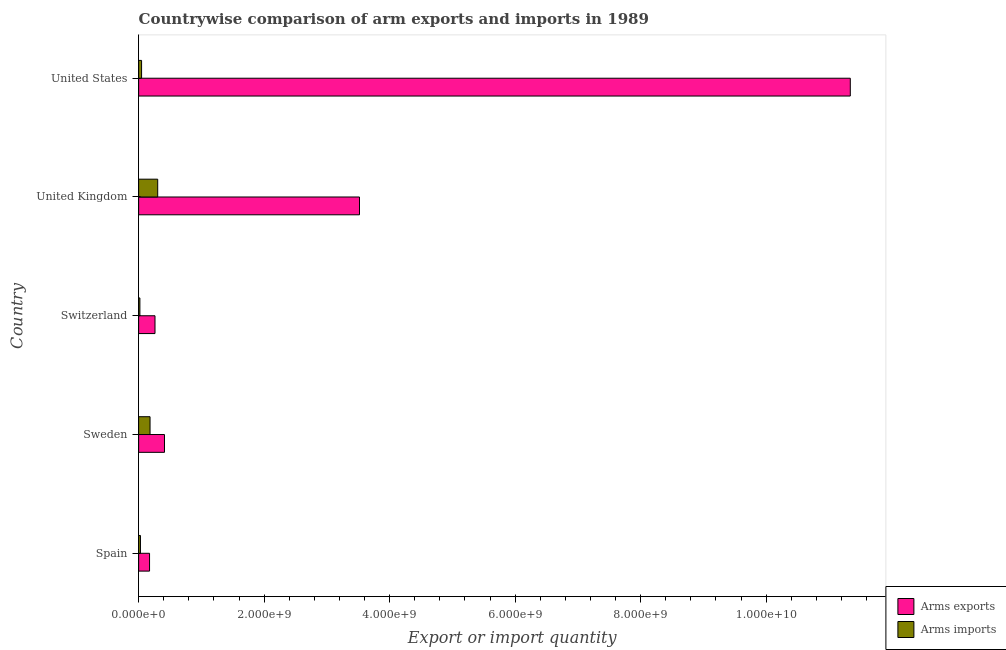How many groups of bars are there?
Offer a terse response. 5. Are the number of bars per tick equal to the number of legend labels?
Offer a terse response. Yes. How many bars are there on the 2nd tick from the top?
Provide a succinct answer. 2. How many bars are there on the 4th tick from the bottom?
Your response must be concise. 2. In how many cases, is the number of bars for a given country not equal to the number of legend labels?
Provide a short and direct response. 0. What is the arms imports in United States?
Make the answer very short. 4.70e+07. Across all countries, what is the maximum arms imports?
Offer a terse response. 3.04e+08. Across all countries, what is the minimum arms imports?
Offer a very short reply. 2.00e+07. What is the total arms imports in the graph?
Ensure brevity in your answer.  5.82e+08. What is the difference between the arms imports in Sweden and that in Switzerland?
Ensure brevity in your answer.  1.62e+08. What is the difference between the arms imports in Sweden and the arms exports in Spain?
Provide a short and direct response. 8.00e+06. What is the average arms imports per country?
Provide a short and direct response. 1.16e+08. What is the difference between the arms imports and arms exports in Spain?
Provide a short and direct response. -1.45e+08. In how many countries, is the arms imports greater than 2400000000 ?
Provide a short and direct response. 0. What is the ratio of the arms imports in Spain to that in United States?
Your answer should be very brief. 0.62. Is the arms exports in United Kingdom less than that in United States?
Make the answer very short. Yes. What is the difference between the highest and the second highest arms imports?
Keep it short and to the point. 1.22e+08. What is the difference between the highest and the lowest arms exports?
Offer a very short reply. 1.12e+1. Is the sum of the arms imports in Spain and Sweden greater than the maximum arms exports across all countries?
Make the answer very short. No. What does the 1st bar from the top in United Kingdom represents?
Ensure brevity in your answer.  Arms imports. What does the 1st bar from the bottom in United States represents?
Make the answer very short. Arms exports. How many bars are there?
Offer a very short reply. 10. How many countries are there in the graph?
Offer a very short reply. 5. What is the difference between two consecutive major ticks on the X-axis?
Keep it short and to the point. 2.00e+09. Are the values on the major ticks of X-axis written in scientific E-notation?
Offer a very short reply. Yes. How are the legend labels stacked?
Make the answer very short. Vertical. What is the title of the graph?
Make the answer very short. Countrywise comparison of arm exports and imports in 1989. What is the label or title of the X-axis?
Keep it short and to the point. Export or import quantity. What is the label or title of the Y-axis?
Provide a succinct answer. Country. What is the Export or import quantity of Arms exports in Spain?
Offer a terse response. 1.74e+08. What is the Export or import quantity in Arms imports in Spain?
Ensure brevity in your answer.  2.90e+07. What is the Export or import quantity of Arms exports in Sweden?
Your answer should be very brief. 4.12e+08. What is the Export or import quantity in Arms imports in Sweden?
Offer a terse response. 1.82e+08. What is the Export or import quantity in Arms exports in Switzerland?
Ensure brevity in your answer.  2.61e+08. What is the Export or import quantity of Arms exports in United Kingdom?
Provide a succinct answer. 3.52e+09. What is the Export or import quantity in Arms imports in United Kingdom?
Ensure brevity in your answer.  3.04e+08. What is the Export or import quantity in Arms exports in United States?
Offer a very short reply. 1.13e+1. What is the Export or import quantity in Arms imports in United States?
Make the answer very short. 4.70e+07. Across all countries, what is the maximum Export or import quantity in Arms exports?
Provide a succinct answer. 1.13e+1. Across all countries, what is the maximum Export or import quantity in Arms imports?
Your answer should be compact. 3.04e+08. Across all countries, what is the minimum Export or import quantity of Arms exports?
Provide a succinct answer. 1.74e+08. What is the total Export or import quantity in Arms exports in the graph?
Make the answer very short. 1.57e+1. What is the total Export or import quantity in Arms imports in the graph?
Your answer should be compact. 5.82e+08. What is the difference between the Export or import quantity of Arms exports in Spain and that in Sweden?
Give a very brief answer. -2.38e+08. What is the difference between the Export or import quantity of Arms imports in Spain and that in Sweden?
Offer a terse response. -1.53e+08. What is the difference between the Export or import quantity of Arms exports in Spain and that in Switzerland?
Offer a terse response. -8.70e+07. What is the difference between the Export or import quantity of Arms imports in Spain and that in Switzerland?
Provide a short and direct response. 9.00e+06. What is the difference between the Export or import quantity in Arms exports in Spain and that in United Kingdom?
Offer a very short reply. -3.35e+09. What is the difference between the Export or import quantity in Arms imports in Spain and that in United Kingdom?
Provide a succinct answer. -2.75e+08. What is the difference between the Export or import quantity in Arms exports in Spain and that in United States?
Provide a short and direct response. -1.12e+1. What is the difference between the Export or import quantity in Arms imports in Spain and that in United States?
Offer a very short reply. -1.80e+07. What is the difference between the Export or import quantity in Arms exports in Sweden and that in Switzerland?
Give a very brief answer. 1.51e+08. What is the difference between the Export or import quantity of Arms imports in Sweden and that in Switzerland?
Keep it short and to the point. 1.62e+08. What is the difference between the Export or import quantity of Arms exports in Sweden and that in United Kingdom?
Keep it short and to the point. -3.11e+09. What is the difference between the Export or import quantity of Arms imports in Sweden and that in United Kingdom?
Give a very brief answer. -1.22e+08. What is the difference between the Export or import quantity of Arms exports in Sweden and that in United States?
Offer a very short reply. -1.09e+1. What is the difference between the Export or import quantity in Arms imports in Sweden and that in United States?
Give a very brief answer. 1.35e+08. What is the difference between the Export or import quantity of Arms exports in Switzerland and that in United Kingdom?
Make the answer very short. -3.26e+09. What is the difference between the Export or import quantity of Arms imports in Switzerland and that in United Kingdom?
Your response must be concise. -2.84e+08. What is the difference between the Export or import quantity in Arms exports in Switzerland and that in United States?
Your answer should be very brief. -1.11e+1. What is the difference between the Export or import quantity of Arms imports in Switzerland and that in United States?
Make the answer very short. -2.70e+07. What is the difference between the Export or import quantity of Arms exports in United Kingdom and that in United States?
Keep it short and to the point. -7.82e+09. What is the difference between the Export or import quantity in Arms imports in United Kingdom and that in United States?
Provide a short and direct response. 2.57e+08. What is the difference between the Export or import quantity of Arms exports in Spain and the Export or import quantity of Arms imports in Sweden?
Your response must be concise. -8.00e+06. What is the difference between the Export or import quantity in Arms exports in Spain and the Export or import quantity in Arms imports in Switzerland?
Give a very brief answer. 1.54e+08. What is the difference between the Export or import quantity in Arms exports in Spain and the Export or import quantity in Arms imports in United Kingdom?
Keep it short and to the point. -1.30e+08. What is the difference between the Export or import quantity of Arms exports in Spain and the Export or import quantity of Arms imports in United States?
Ensure brevity in your answer.  1.27e+08. What is the difference between the Export or import quantity of Arms exports in Sweden and the Export or import quantity of Arms imports in Switzerland?
Offer a very short reply. 3.92e+08. What is the difference between the Export or import quantity in Arms exports in Sweden and the Export or import quantity in Arms imports in United Kingdom?
Provide a short and direct response. 1.08e+08. What is the difference between the Export or import quantity in Arms exports in Sweden and the Export or import quantity in Arms imports in United States?
Your answer should be very brief. 3.65e+08. What is the difference between the Export or import quantity in Arms exports in Switzerland and the Export or import quantity in Arms imports in United Kingdom?
Your answer should be very brief. -4.30e+07. What is the difference between the Export or import quantity in Arms exports in Switzerland and the Export or import quantity in Arms imports in United States?
Offer a terse response. 2.14e+08. What is the difference between the Export or import quantity in Arms exports in United Kingdom and the Export or import quantity in Arms imports in United States?
Offer a terse response. 3.47e+09. What is the average Export or import quantity of Arms exports per country?
Provide a succinct answer. 3.14e+09. What is the average Export or import quantity of Arms imports per country?
Offer a terse response. 1.16e+08. What is the difference between the Export or import quantity in Arms exports and Export or import quantity in Arms imports in Spain?
Provide a succinct answer. 1.45e+08. What is the difference between the Export or import quantity in Arms exports and Export or import quantity in Arms imports in Sweden?
Provide a short and direct response. 2.30e+08. What is the difference between the Export or import quantity of Arms exports and Export or import quantity of Arms imports in Switzerland?
Give a very brief answer. 2.41e+08. What is the difference between the Export or import quantity in Arms exports and Export or import quantity in Arms imports in United Kingdom?
Provide a short and direct response. 3.22e+09. What is the difference between the Export or import quantity in Arms exports and Export or import quantity in Arms imports in United States?
Your response must be concise. 1.13e+1. What is the ratio of the Export or import quantity in Arms exports in Spain to that in Sweden?
Your answer should be compact. 0.42. What is the ratio of the Export or import quantity of Arms imports in Spain to that in Sweden?
Your response must be concise. 0.16. What is the ratio of the Export or import quantity in Arms imports in Spain to that in Switzerland?
Provide a succinct answer. 1.45. What is the ratio of the Export or import quantity in Arms exports in Spain to that in United Kingdom?
Your answer should be compact. 0.05. What is the ratio of the Export or import quantity of Arms imports in Spain to that in United Kingdom?
Offer a very short reply. 0.1. What is the ratio of the Export or import quantity of Arms exports in Spain to that in United States?
Keep it short and to the point. 0.02. What is the ratio of the Export or import quantity in Arms imports in Spain to that in United States?
Make the answer very short. 0.62. What is the ratio of the Export or import quantity in Arms exports in Sweden to that in Switzerland?
Your answer should be compact. 1.58. What is the ratio of the Export or import quantity of Arms exports in Sweden to that in United Kingdom?
Ensure brevity in your answer.  0.12. What is the ratio of the Export or import quantity in Arms imports in Sweden to that in United Kingdom?
Your answer should be very brief. 0.6. What is the ratio of the Export or import quantity in Arms exports in Sweden to that in United States?
Your response must be concise. 0.04. What is the ratio of the Export or import quantity in Arms imports in Sweden to that in United States?
Provide a short and direct response. 3.87. What is the ratio of the Export or import quantity of Arms exports in Switzerland to that in United Kingdom?
Keep it short and to the point. 0.07. What is the ratio of the Export or import quantity of Arms imports in Switzerland to that in United Kingdom?
Your answer should be compact. 0.07. What is the ratio of the Export or import quantity in Arms exports in Switzerland to that in United States?
Your answer should be very brief. 0.02. What is the ratio of the Export or import quantity of Arms imports in Switzerland to that in United States?
Your response must be concise. 0.43. What is the ratio of the Export or import quantity of Arms exports in United Kingdom to that in United States?
Offer a very short reply. 0.31. What is the ratio of the Export or import quantity in Arms imports in United Kingdom to that in United States?
Your answer should be compact. 6.47. What is the difference between the highest and the second highest Export or import quantity of Arms exports?
Provide a short and direct response. 7.82e+09. What is the difference between the highest and the second highest Export or import quantity in Arms imports?
Provide a short and direct response. 1.22e+08. What is the difference between the highest and the lowest Export or import quantity of Arms exports?
Your response must be concise. 1.12e+1. What is the difference between the highest and the lowest Export or import quantity of Arms imports?
Make the answer very short. 2.84e+08. 